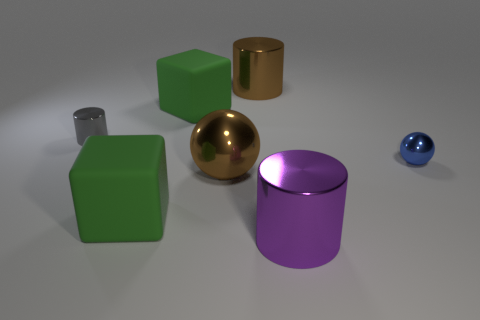Add 2 large rubber objects. How many objects exist? 9 Subtract all large metal cylinders. How many cylinders are left? 1 Subtract all cylinders. How many objects are left? 4 Add 5 blue shiny balls. How many blue shiny balls exist? 6 Subtract 0 purple balls. How many objects are left? 7 Subtract all large shiny cylinders. Subtract all big cylinders. How many objects are left? 3 Add 5 blue spheres. How many blue spheres are left? 6 